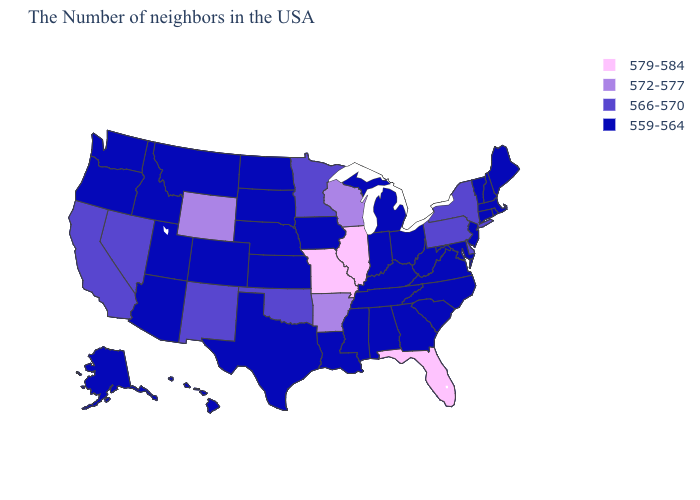Among the states that border Rhode Island , which have the highest value?
Be succinct. Massachusetts, Connecticut. Which states have the highest value in the USA?
Short answer required. Florida, Illinois, Missouri. Does Wyoming have the highest value in the West?
Answer briefly. Yes. What is the highest value in the USA?
Quick response, please. 579-584. Which states have the lowest value in the MidWest?
Write a very short answer. Ohio, Michigan, Indiana, Iowa, Kansas, Nebraska, South Dakota, North Dakota. What is the value of Florida?
Write a very short answer. 579-584. Name the states that have a value in the range 572-577?
Quick response, please. Wisconsin, Arkansas, Wyoming. Which states have the lowest value in the South?
Concise answer only. Maryland, Virginia, North Carolina, South Carolina, West Virginia, Georgia, Kentucky, Alabama, Tennessee, Mississippi, Louisiana, Texas. What is the value of Georgia?
Give a very brief answer. 559-564. Among the states that border Alabama , does Georgia have the lowest value?
Give a very brief answer. Yes. Among the states that border Tennessee , does Missouri have the highest value?
Be succinct. Yes. What is the value of Massachusetts?
Quick response, please. 559-564. Name the states that have a value in the range 566-570?
Concise answer only. New York, Delaware, Pennsylvania, Minnesota, Oklahoma, New Mexico, Nevada, California. What is the lowest value in the West?
Answer briefly. 559-564. 